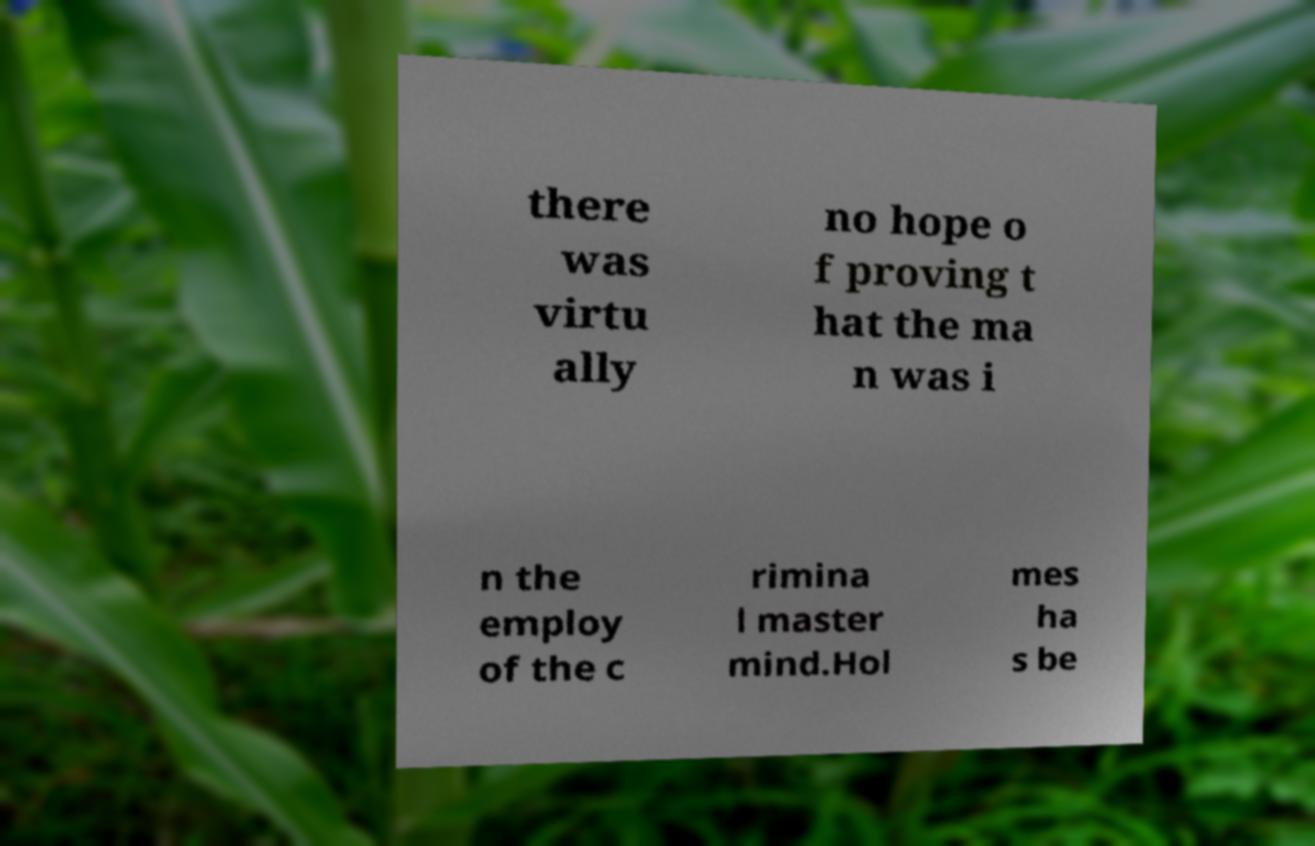For documentation purposes, I need the text within this image transcribed. Could you provide that? there was virtu ally no hope o f proving t hat the ma n was i n the employ of the c rimina l master mind.Hol mes ha s be 